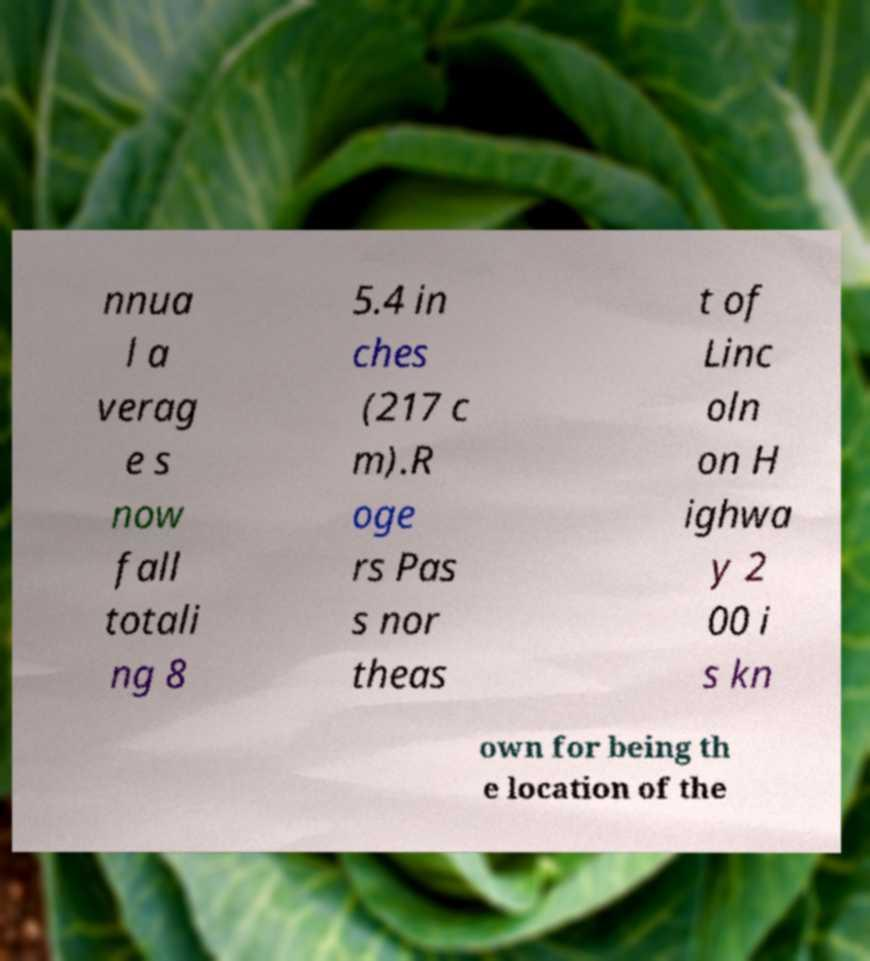There's text embedded in this image that I need extracted. Can you transcribe it verbatim? nnua l a verag e s now fall totali ng 8 5.4 in ches (217 c m).R oge rs Pas s nor theas t of Linc oln on H ighwa y 2 00 i s kn own for being th e location of the 